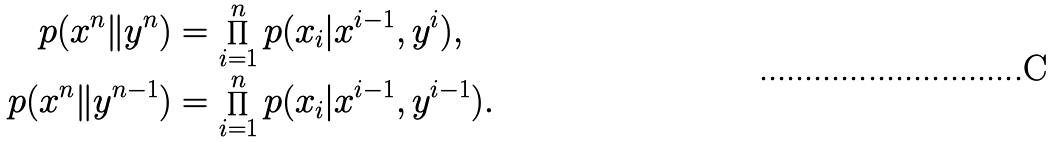<formula> <loc_0><loc_0><loc_500><loc_500>p ( x ^ { n } \| y ^ { n } ) & = \prod _ { i = 1 } ^ { n } p ( x _ { i } | x ^ { i - 1 } , y ^ { i } ) , \\ p ( x ^ { n } \| y ^ { n - 1 } ) & = \prod _ { i = 1 } ^ { n } p ( x _ { i } | x ^ { i - 1 } , y ^ { i - 1 } ) .</formula> 